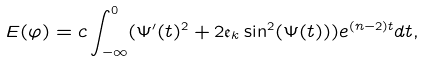<formula> <loc_0><loc_0><loc_500><loc_500>E ( \varphi ) = c \int _ { - \infty } ^ { 0 } ( \Psi ^ { \prime } ( t ) ^ { 2 } + 2 \mathfrak { e } _ { k } \sin ^ { 2 } ( \Psi ( t ) ) ) e ^ { ( n - 2 ) t } d t ,</formula> 